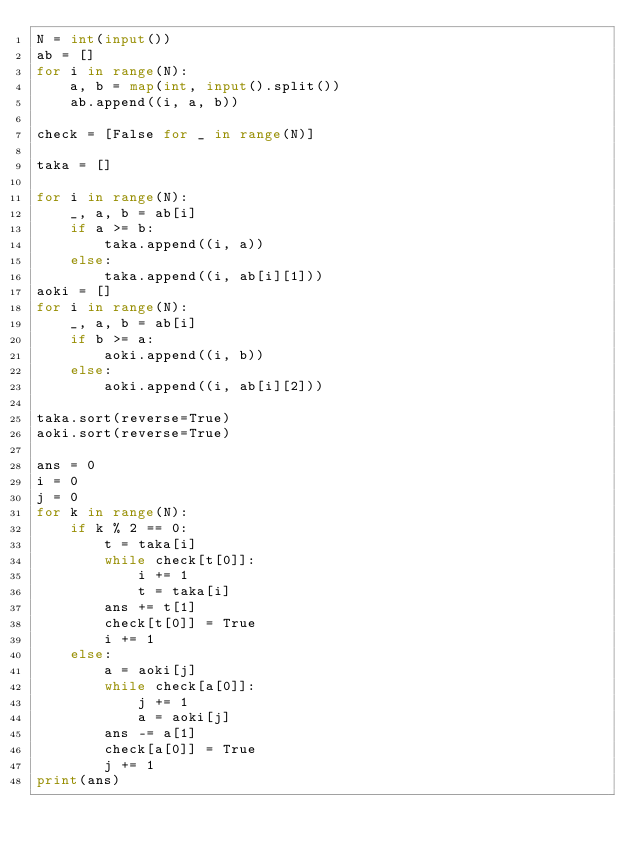<code> <loc_0><loc_0><loc_500><loc_500><_Python_>N = int(input())
ab = []
for i in range(N):
    a, b = map(int, input().split())
    ab.append((i, a, b))

check = [False for _ in range(N)]

taka = []

for i in range(N):
    _, a, b = ab[i]
    if a >= b:
        taka.append((i, a))
    else:
        taka.append((i, ab[i][1]))
aoki = []
for i in range(N):
    _, a, b = ab[i]
    if b >= a:
        aoki.append((i, b))
    else:
        aoki.append((i, ab[i][2]))

taka.sort(reverse=True)
aoki.sort(reverse=True)

ans = 0
i = 0
j = 0
for k in range(N):
    if k % 2 == 0:
        t = taka[i]
        while check[t[0]]:
            i += 1
            t = taka[i]
        ans += t[1]
        check[t[0]] = True
        i += 1
    else:
        a = aoki[j]
        while check[a[0]]:
            j += 1
            a = aoki[j]
        ans -= a[1]
        check[a[0]] = True
        j += 1
print(ans)


</code> 